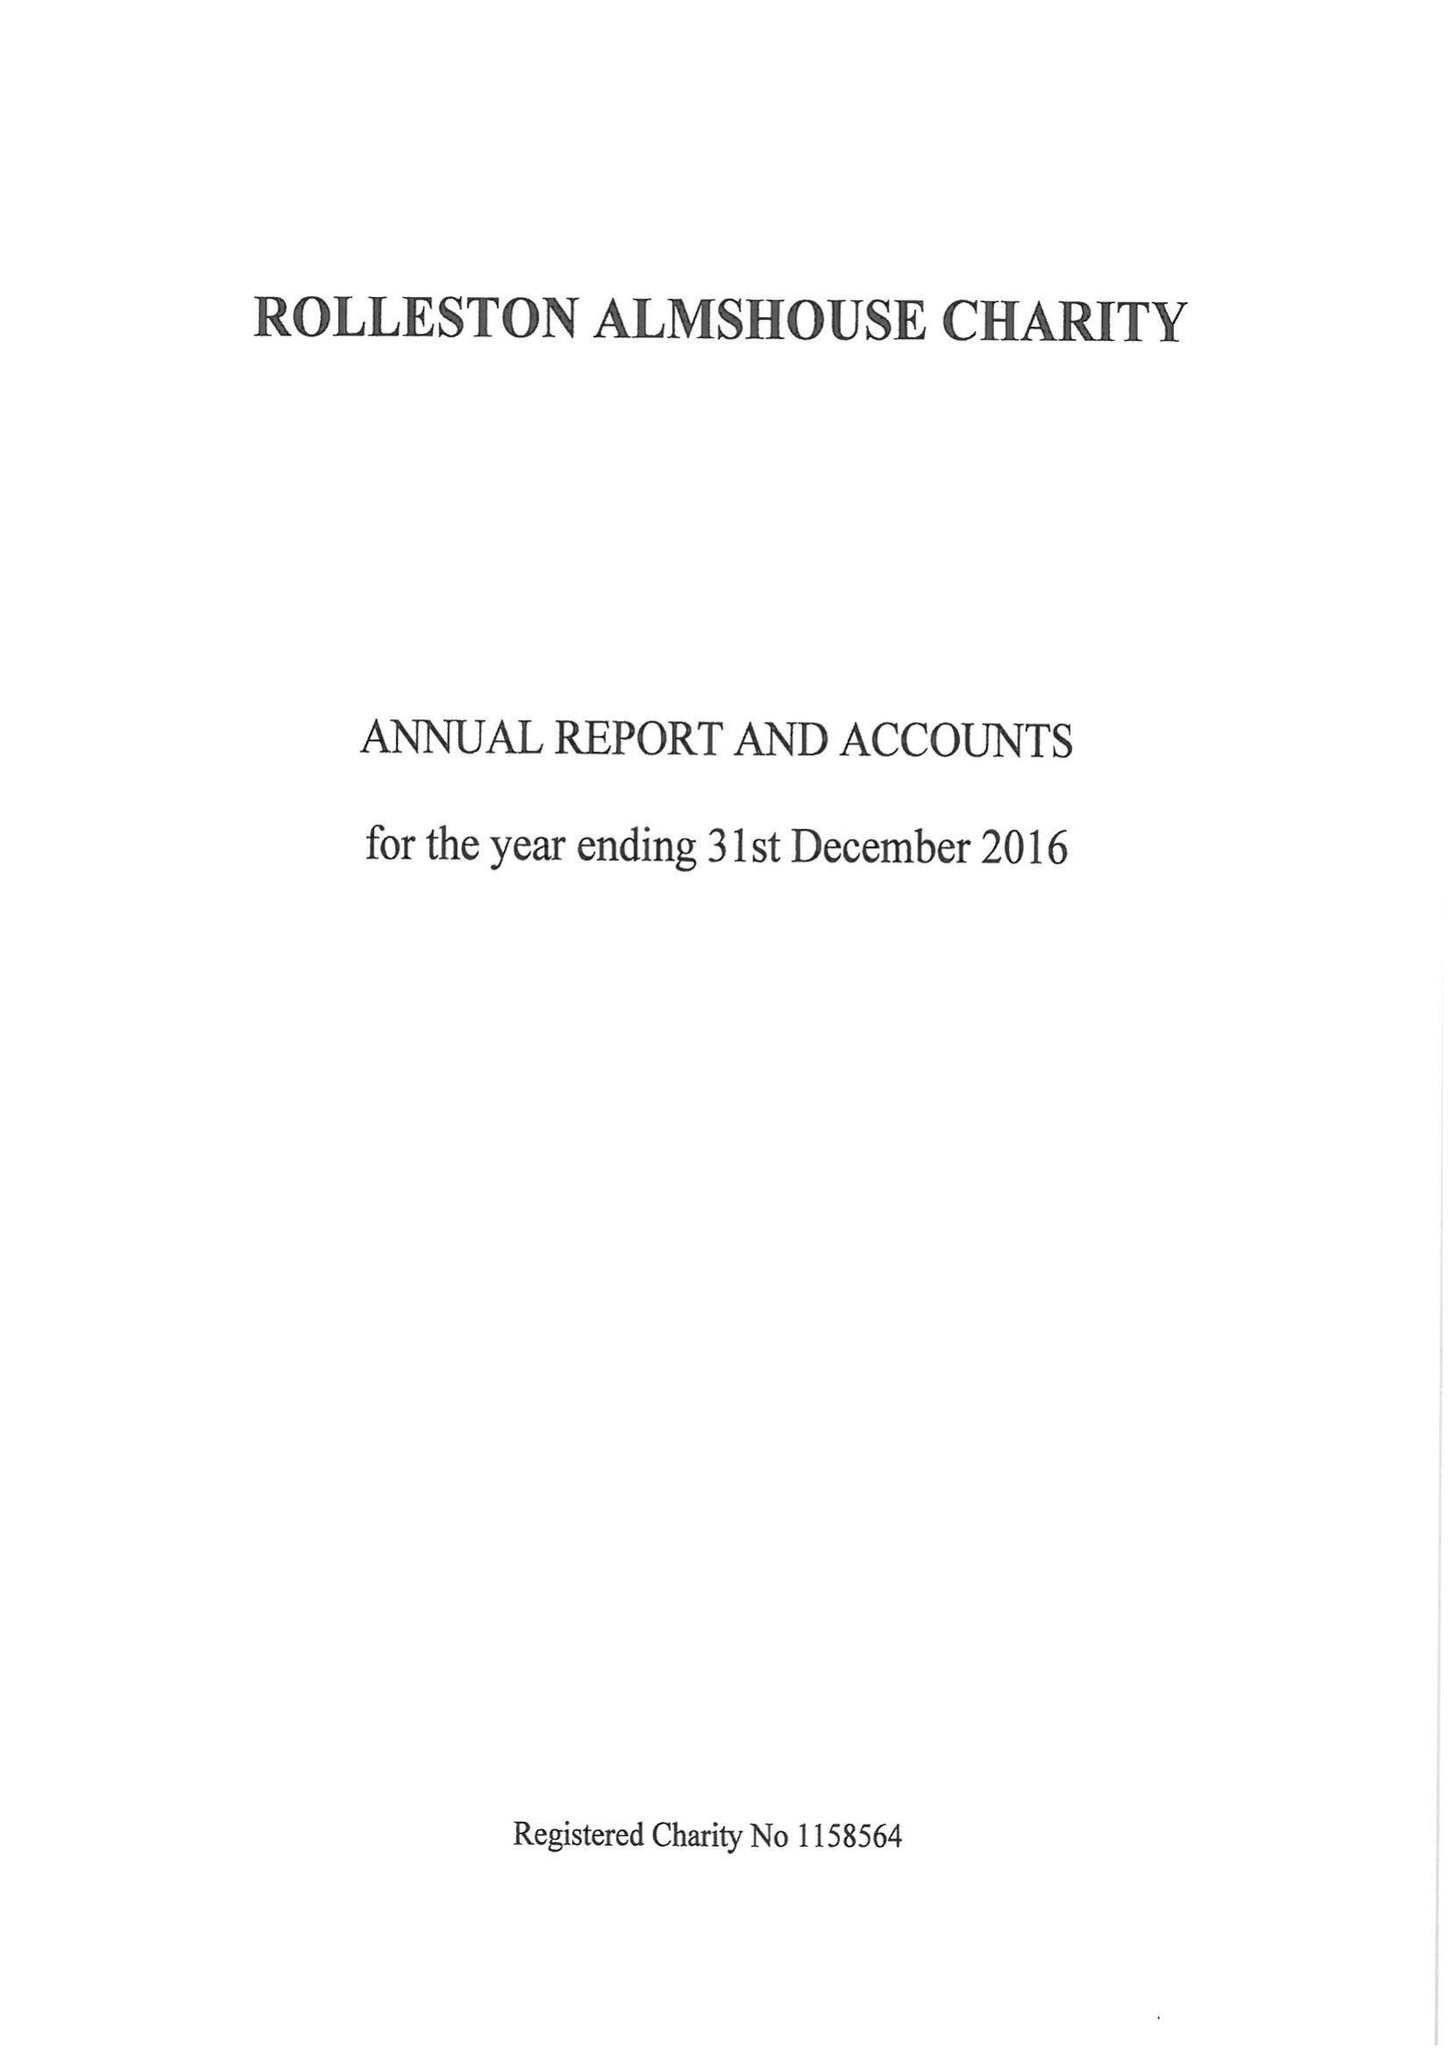What is the value for the charity_name?
Answer the question using a single word or phrase. Rolleston Almshouse Charity 